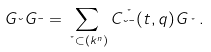<formula> <loc_0><loc_0><loc_500><loc_500>G _ { \lambda } G _ { \mu } = \sum _ { \nu \subset ( k ^ { n } ) } C _ { \lambda \mu } ^ { \nu } ( t , q ) G _ { \nu } \, .</formula> 